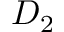<formula> <loc_0><loc_0><loc_500><loc_500>D _ { 2 }</formula> 